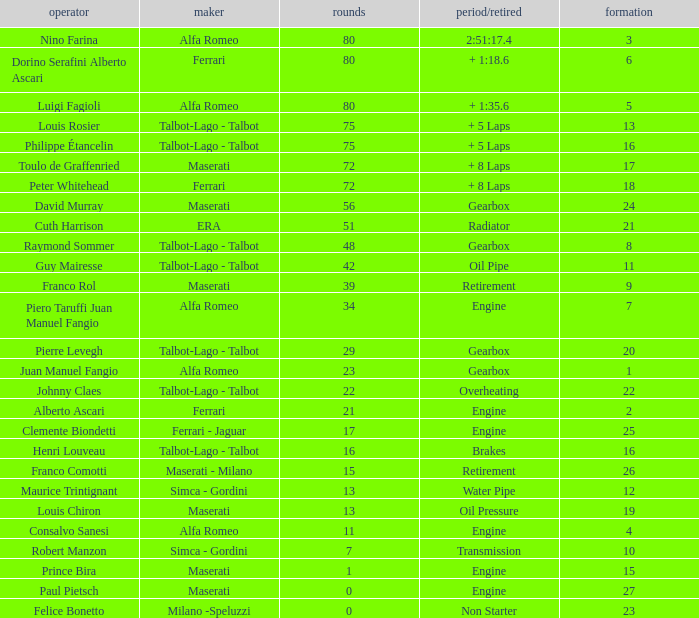What was the smallest grid for Prince bira? 15.0. 